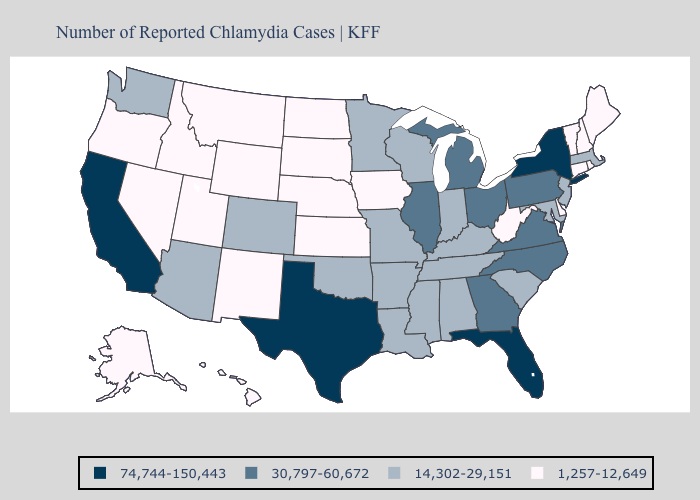Does South Dakota have a lower value than Hawaii?
Keep it brief. No. What is the highest value in states that border Arizona?
Be succinct. 74,744-150,443. Which states have the lowest value in the MidWest?
Be succinct. Iowa, Kansas, Nebraska, North Dakota, South Dakota. Which states have the lowest value in the USA?
Give a very brief answer. Alaska, Connecticut, Delaware, Hawaii, Idaho, Iowa, Kansas, Maine, Montana, Nebraska, Nevada, New Hampshire, New Mexico, North Dakota, Oregon, Rhode Island, South Dakota, Utah, Vermont, West Virginia, Wyoming. What is the highest value in states that border Nebraska?
Answer briefly. 14,302-29,151. What is the lowest value in the South?
Answer briefly. 1,257-12,649. What is the value of Maine?
Be succinct. 1,257-12,649. Does the first symbol in the legend represent the smallest category?
Keep it brief. No. What is the value of Colorado?
Answer briefly. 14,302-29,151. Name the states that have a value in the range 14,302-29,151?
Give a very brief answer. Alabama, Arizona, Arkansas, Colorado, Indiana, Kentucky, Louisiana, Maryland, Massachusetts, Minnesota, Mississippi, Missouri, New Jersey, Oklahoma, South Carolina, Tennessee, Washington, Wisconsin. Which states have the highest value in the USA?
Concise answer only. California, Florida, New York, Texas. Name the states that have a value in the range 1,257-12,649?
Answer briefly. Alaska, Connecticut, Delaware, Hawaii, Idaho, Iowa, Kansas, Maine, Montana, Nebraska, Nevada, New Hampshire, New Mexico, North Dakota, Oregon, Rhode Island, South Dakota, Utah, Vermont, West Virginia, Wyoming. What is the highest value in the Northeast ?
Keep it brief. 74,744-150,443. What is the value of South Dakota?
Answer briefly. 1,257-12,649. Which states have the lowest value in the MidWest?
Be succinct. Iowa, Kansas, Nebraska, North Dakota, South Dakota. 